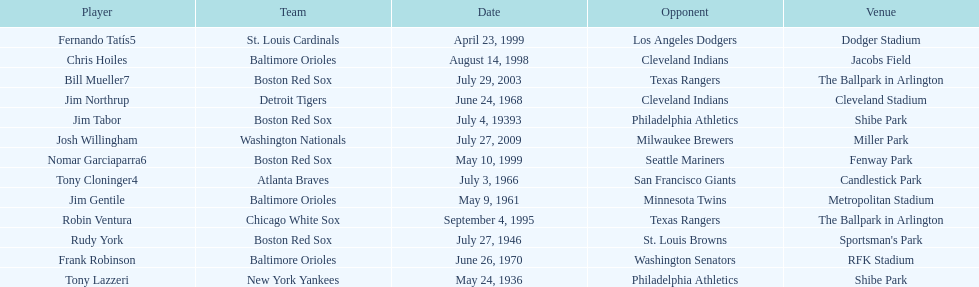Which teams faced off at miller park? Washington Nationals, Milwaukee Brewers. 